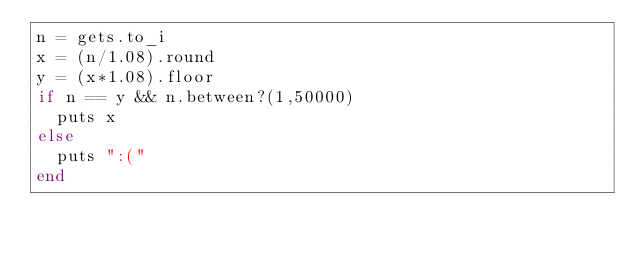<code> <loc_0><loc_0><loc_500><loc_500><_Ruby_>n = gets.to_i
x = (n/1.08).round
y = (x*1.08).floor
if n == y && n.between?(1,50000)
  puts x
else
  puts ":("
end
</code> 